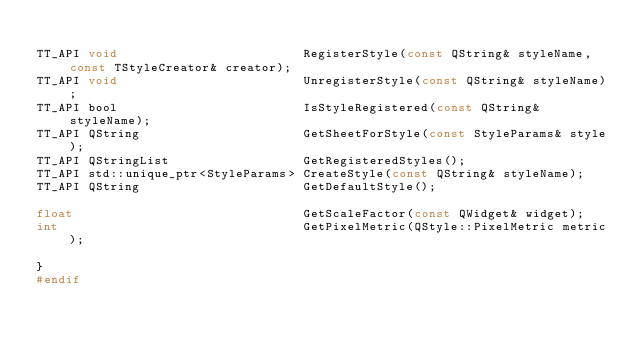Convert code to text. <code><loc_0><loc_0><loc_500><loc_500><_C_>
TT_API void                         RegisterStyle(const QString& styleName, const TStyleCreator& creator);
TT_API void                         UnregisterStyle(const QString& styleName);
TT_API bool                         IsStyleRegistered(const QString& styleName);
TT_API QString                      GetSheetForStyle(const StyleParams& style);
TT_API QStringList                  GetRegisteredStyles();
TT_API std::unique_ptr<StyleParams> CreateStyle(const QString& styleName);
TT_API QString                      GetDefaultStyle();

float                               GetScaleFactor(const QWidget& widget);
int                                 GetPixelMetric(QStyle::PixelMetric metric);

}
#endif
</code> 